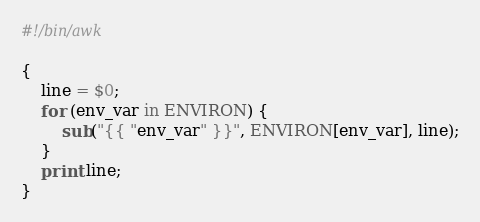<code> <loc_0><loc_0><loc_500><loc_500><_Awk_>#!/bin/awk

{
    line = $0;
    for (env_var in ENVIRON) {
        sub("{{ "env_var" }}", ENVIRON[env_var], line);
    }
    print line;
}
</code> 